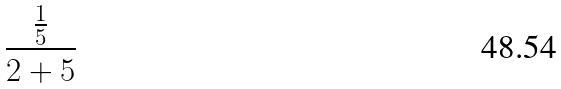<formula> <loc_0><loc_0><loc_500><loc_500>\frac { \frac { 1 } { 5 } } { 2 + 5 }</formula> 